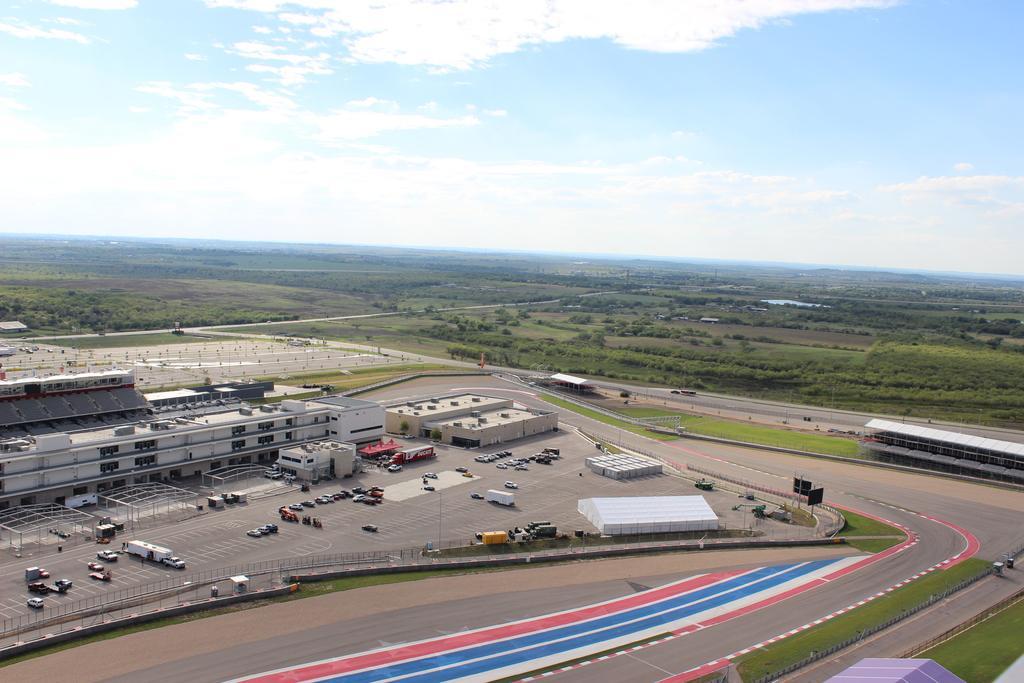Describe this image in one or two sentences. In this image there is the sky towards the top of the image, there are clouds in the sky, there are trees, there is grass, there is road, there are buildings, there are vehicles parked, there is an object towards the bottom of the image, there are poles, there are boards, there is an object towards the right of the image, there is a fence towards the left of the image. 